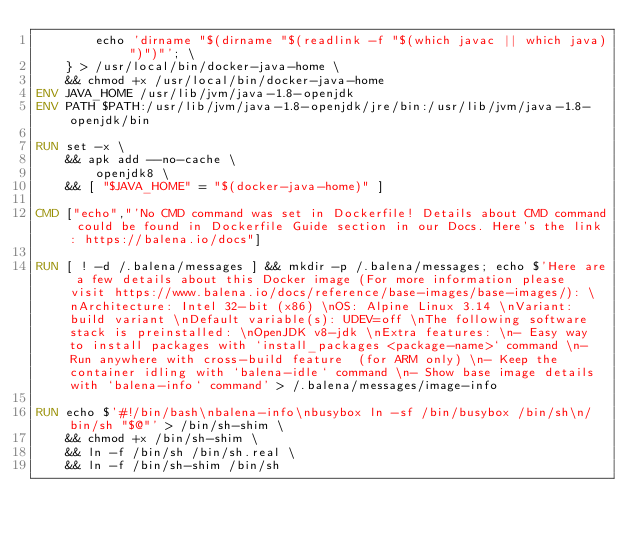<code> <loc_0><loc_0><loc_500><loc_500><_Dockerfile_>		echo 'dirname "$(dirname "$(readlink -f "$(which javac || which java)")")"'; \
	} > /usr/local/bin/docker-java-home \
	&& chmod +x /usr/local/bin/docker-java-home
ENV JAVA_HOME /usr/lib/jvm/java-1.8-openjdk
ENV PATH $PATH:/usr/lib/jvm/java-1.8-openjdk/jre/bin:/usr/lib/jvm/java-1.8-openjdk/bin

RUN set -x \
	&& apk add --no-cache \
		openjdk8 \
	&& [ "$JAVA_HOME" = "$(docker-java-home)" ]

CMD ["echo","'No CMD command was set in Dockerfile! Details about CMD command could be found in Dockerfile Guide section in our Docs. Here's the link: https://balena.io/docs"]

RUN [ ! -d /.balena/messages ] && mkdir -p /.balena/messages; echo $'Here are a few details about this Docker image (For more information please visit https://www.balena.io/docs/reference/base-images/base-images/): \nArchitecture: Intel 32-bit (x86) \nOS: Alpine Linux 3.14 \nVariant: build variant \nDefault variable(s): UDEV=off \nThe following software stack is preinstalled: \nOpenJDK v8-jdk \nExtra features: \n- Easy way to install packages with `install_packages <package-name>` command \n- Run anywhere with cross-build feature  (for ARM only) \n- Keep the container idling with `balena-idle` command \n- Show base image details with `balena-info` command' > /.balena/messages/image-info

RUN echo $'#!/bin/bash\nbalena-info\nbusybox ln -sf /bin/busybox /bin/sh\n/bin/sh "$@"' > /bin/sh-shim \
	&& chmod +x /bin/sh-shim \
	&& ln -f /bin/sh /bin/sh.real \
	&& ln -f /bin/sh-shim /bin/sh</code> 